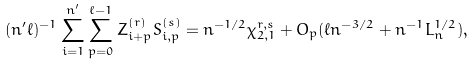Convert formula to latex. <formula><loc_0><loc_0><loc_500><loc_500>( n ^ { \prime } \ell ) ^ { - 1 } \sum _ { i = 1 } ^ { n ^ { \prime } } \sum _ { p = 0 } ^ { \ell - 1 } Z ^ { ( r ) } _ { i + p } S _ { i , p } ^ { ( s ) } = n ^ { - 1 / 2 } \chi ^ { r , s } _ { 2 , 1 } + O _ { p } ( \ell n ^ { - 3 / 2 } + n ^ { - 1 } L _ { n } ^ { 1 / 2 } ) ,</formula> 